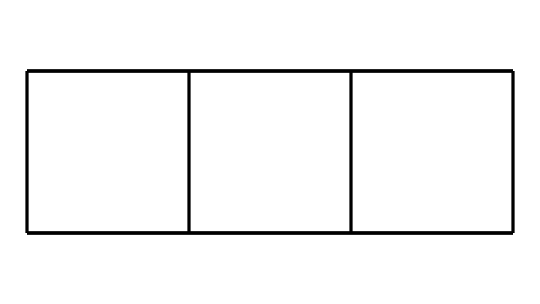What is the name of this chemical compound? The structure represents cubane, which is a well-known cage compound. The specific arrangement of carbons and hydrogens confirms this.
Answer: cubane How many carbon atoms are present in this structure? By analyzing the SMILES representation, it is identified that there are eight carbon atoms in the cubane molecule.
Answer: eight How many hydrogen atoms does cubane have? Each carbon in the structure forms bonds according to tetravalency. Given the structure has eight carbons, it has a total of sixteen hydrogen atoms, filling the bonds adequately.
Answer: sixteen What type of structure does cubane have? Cubane is classified as a cage compound due to its unique three-dimensional cubic arrangement of carbon atoms. This is evident in the bond connections shown in the visual structure.
Answer: cage What is the molecular formula of cubane? By combining the number of carbons and hydrogens identified in the molecule, the molecular formula can be deduced as C8H16.
Answer: C8H16 How does the structure of cubane relate to its energy density? Cubane's compact structure allows for a high energy density due to efficient packing and potential for high energy release when burned, as indicated by its three-dimensional arrangement.
Answer: high energy density 